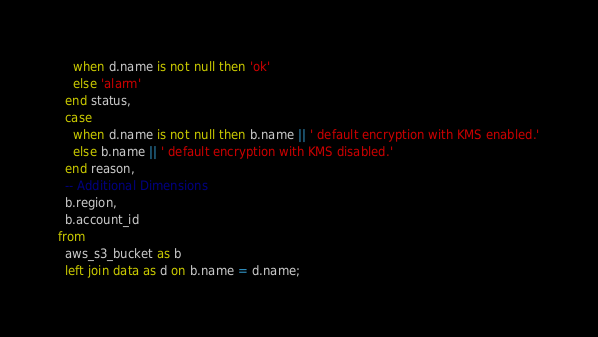Convert code to text. <code><loc_0><loc_0><loc_500><loc_500><_SQL_>    when d.name is not null then 'ok'
    else 'alarm'
  end status,
  case
    when d.name is not null then b.name || ' default encryption with KMS enabled.'
    else b.name || ' default encryption with KMS disabled.'
  end reason,
  -- Additional Dimensions
  b.region,
  b.account_id
from
  aws_s3_bucket as b
  left join data as d on b.name = d.name;</code> 